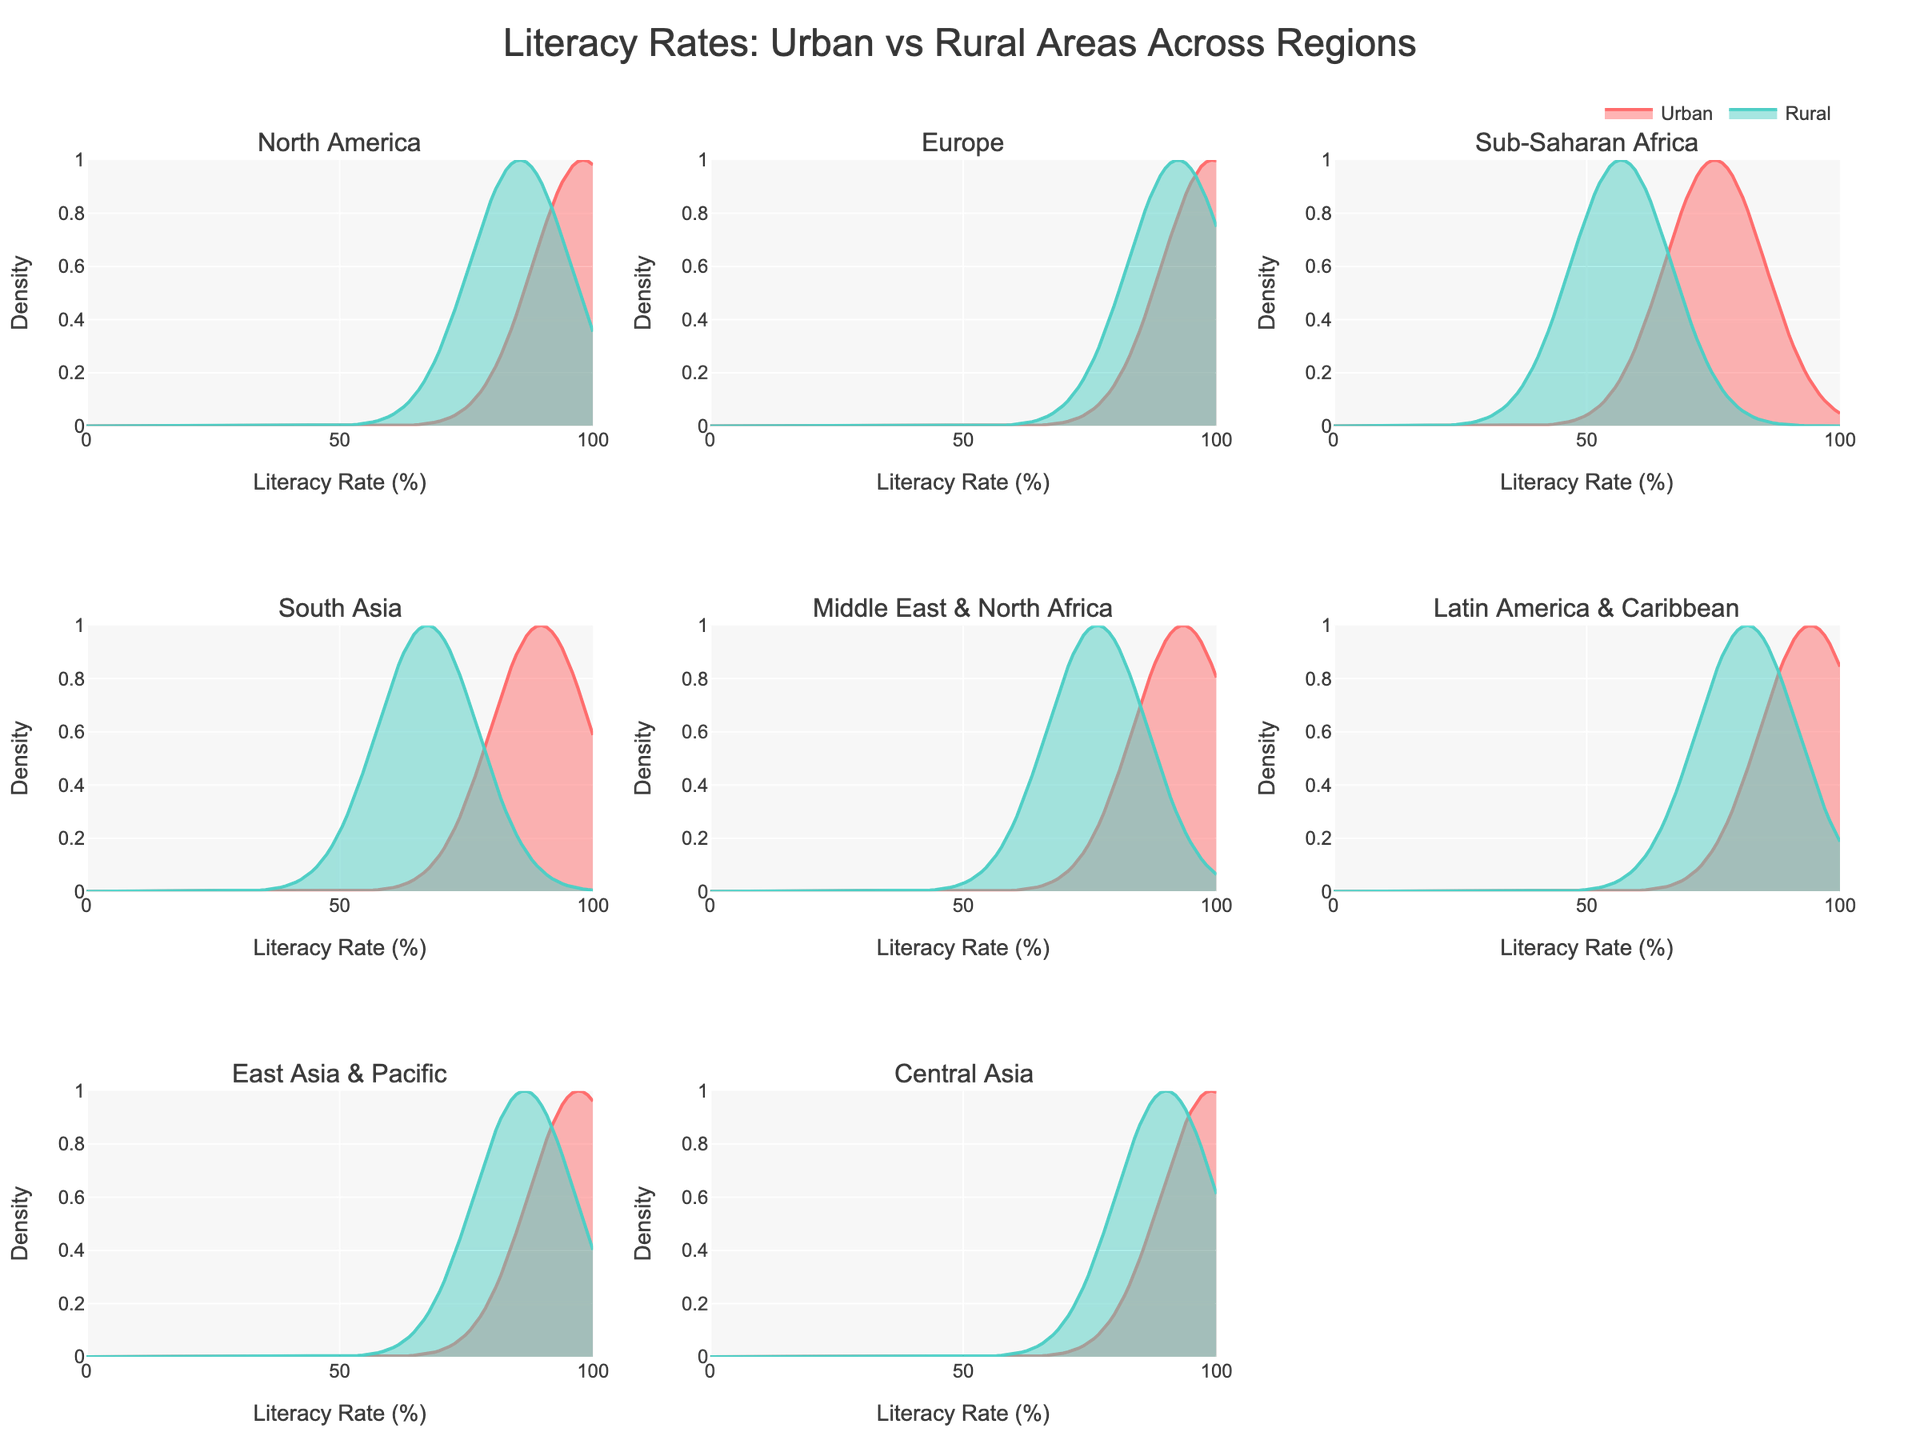What is the overall title of the figure? The title is typically located at the top of the figure and summarizes the main topic being depicted.
Answer: "Literacy Rates: Urban vs Rural Areas Across Regions" How is the literacy rate depicted for each region? In the figure, literacy rates for each region are depicted using density plots. Each subplot represents a different region, and curves of different colors show the distribution of literacy rates for urban and rural areas within that region.
Answer: Density plots Which region has the highest urban literacy rate? To determine this, we need to compare the peaks of the urban literacy rate curves across all subplots. The maximum point across all urban curves gives the answer.
Answer: Europe (99.2%) In which region is the gap between urban and rural literacy rates the largest? We calculate the difference between urban and rural literacy rates for each region and compare these differences to find the largest one. For example, for Sub-Saharan Africa, the difference is 75.3 - 56.8 = 18.5. Repeat this for each region to find the largest difference.
Answer: Sub-Saharan Africa (18.5%) Which regions have literacy rates above 90% in rural areas? Examine rural literacy rate figures for each subplot. Compare them with 90% and identify those regions with rural literacy rates exceeding this value.
Answer: Europe, Central Asia Are there any regions where the rural literacy rate exceeds the urban literacy rate? Compare the literacy rate for rural and urban areas within each subplot. Since urban literacy rates are universally higher, there will be no region where rural rates exceed urban rates.
Answer: No Is the literacy rate distribution more concentrated in urban or rural areas across regions? By observing the spread of density curves (their width), we see that curves with smaller spreads (more concentrated) depict more uniformity. Typically, urban curves are narrower and taller, indicating higher concentration around their means.
Answer: Urban areas Which region shows the smallest difference between urban and rural literacy rates? Determine the differences between urban and rural literacy rates for each region and find the one with the smallest difference. For example, for the Middle East & North Africa, the difference is 93.4 - 76.5 = 16.9. Compare all values to identify the smallest one.
Answer: Central Asia (8.9%) What is the literacy rate range covered by the density plots? The x-axis range is explicitly labeled on the figure, showing the span in literacy percentages depicted by the plots.
Answer: 0 to 100% Are literacy rates higher in urban or rural areas across all regions? Compare the peaks of the curves within each subplot. Across all regions, the urban area's peak is higher than the rural area's, indicating higher literacy rates.
Answer: Urban areas 